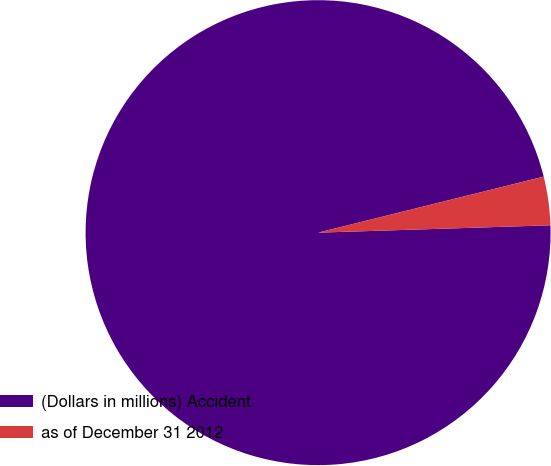Convert chart. <chart><loc_0><loc_0><loc_500><loc_500><pie_chart><fcel>(Dollars in millions) Accident<fcel>as of December 31 2012<nl><fcel>96.63%<fcel>3.37%<nl></chart> 